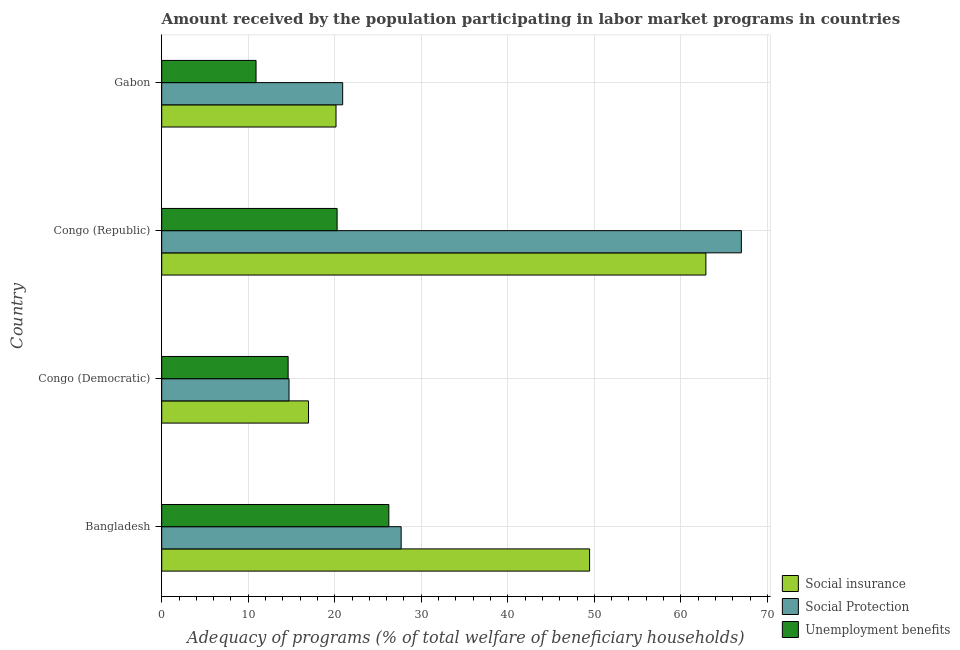How many bars are there on the 3rd tick from the top?
Give a very brief answer. 3. How many bars are there on the 3rd tick from the bottom?
Provide a short and direct response. 3. What is the label of the 2nd group of bars from the top?
Provide a short and direct response. Congo (Republic). What is the amount received by the population participating in unemployment benefits programs in Congo (Democratic)?
Your response must be concise. 14.61. Across all countries, what is the maximum amount received by the population participating in social protection programs?
Your response must be concise. 66.99. Across all countries, what is the minimum amount received by the population participating in unemployment benefits programs?
Give a very brief answer. 10.9. In which country was the amount received by the population participating in social protection programs maximum?
Your answer should be compact. Congo (Republic). In which country was the amount received by the population participating in social insurance programs minimum?
Offer a very short reply. Congo (Democratic). What is the total amount received by the population participating in unemployment benefits programs in the graph?
Your answer should be compact. 72.04. What is the difference between the amount received by the population participating in social insurance programs in Bangladesh and that in Congo (Democratic)?
Ensure brevity in your answer.  32.49. What is the difference between the amount received by the population participating in social insurance programs in Bangladesh and the amount received by the population participating in social protection programs in Congo (Republic)?
Your answer should be very brief. -17.54. What is the average amount received by the population participating in social insurance programs per country?
Ensure brevity in your answer.  37.36. What is the difference between the amount received by the population participating in social insurance programs and amount received by the population participating in unemployment benefits programs in Congo (Republic)?
Ensure brevity in your answer.  42.62. In how many countries, is the amount received by the population participating in unemployment benefits programs greater than 24 %?
Offer a very short reply. 1. What is the ratio of the amount received by the population participating in social protection programs in Congo (Republic) to that in Gabon?
Keep it short and to the point. 3.2. Is the amount received by the population participating in unemployment benefits programs in Congo (Democratic) less than that in Gabon?
Provide a succinct answer. No. Is the difference between the amount received by the population participating in social protection programs in Bangladesh and Gabon greater than the difference between the amount received by the population participating in social insurance programs in Bangladesh and Gabon?
Provide a succinct answer. No. What is the difference between the highest and the second highest amount received by the population participating in social protection programs?
Your response must be concise. 39.32. What is the difference between the highest and the lowest amount received by the population participating in unemployment benefits programs?
Make the answer very short. 15.35. In how many countries, is the amount received by the population participating in social protection programs greater than the average amount received by the population participating in social protection programs taken over all countries?
Your answer should be compact. 1. What does the 1st bar from the top in Gabon represents?
Your response must be concise. Unemployment benefits. What does the 3rd bar from the bottom in Congo (Republic) represents?
Provide a short and direct response. Unemployment benefits. Is it the case that in every country, the sum of the amount received by the population participating in social insurance programs and amount received by the population participating in social protection programs is greater than the amount received by the population participating in unemployment benefits programs?
Provide a succinct answer. Yes. How many bars are there?
Keep it short and to the point. 12. How many countries are there in the graph?
Keep it short and to the point. 4. Are the values on the major ticks of X-axis written in scientific E-notation?
Provide a short and direct response. No. What is the title of the graph?
Ensure brevity in your answer.  Amount received by the population participating in labor market programs in countries. What is the label or title of the X-axis?
Ensure brevity in your answer.  Adequacy of programs (% of total welfare of beneficiary households). What is the label or title of the Y-axis?
Offer a terse response. Country. What is the Adequacy of programs (% of total welfare of beneficiary households) in Social insurance in Bangladesh?
Ensure brevity in your answer.  49.45. What is the Adequacy of programs (% of total welfare of beneficiary households) of Social Protection in Bangladesh?
Your answer should be compact. 27.67. What is the Adequacy of programs (% of total welfare of beneficiary households) in Unemployment benefits in Bangladesh?
Ensure brevity in your answer.  26.25. What is the Adequacy of programs (% of total welfare of beneficiary households) in Social insurance in Congo (Democratic)?
Ensure brevity in your answer.  16.97. What is the Adequacy of programs (% of total welfare of beneficiary households) in Social Protection in Congo (Democratic)?
Make the answer very short. 14.72. What is the Adequacy of programs (% of total welfare of beneficiary households) of Unemployment benefits in Congo (Democratic)?
Your answer should be compact. 14.61. What is the Adequacy of programs (% of total welfare of beneficiary households) of Social insurance in Congo (Republic)?
Offer a terse response. 62.89. What is the Adequacy of programs (% of total welfare of beneficiary households) in Social Protection in Congo (Republic)?
Your answer should be compact. 66.99. What is the Adequacy of programs (% of total welfare of beneficiary households) of Unemployment benefits in Congo (Republic)?
Offer a very short reply. 20.27. What is the Adequacy of programs (% of total welfare of beneficiary households) of Social insurance in Gabon?
Offer a very short reply. 20.14. What is the Adequacy of programs (% of total welfare of beneficiary households) of Social Protection in Gabon?
Offer a very short reply. 20.91. What is the Adequacy of programs (% of total welfare of beneficiary households) of Unemployment benefits in Gabon?
Provide a short and direct response. 10.9. Across all countries, what is the maximum Adequacy of programs (% of total welfare of beneficiary households) of Social insurance?
Give a very brief answer. 62.89. Across all countries, what is the maximum Adequacy of programs (% of total welfare of beneficiary households) in Social Protection?
Offer a terse response. 66.99. Across all countries, what is the maximum Adequacy of programs (% of total welfare of beneficiary households) of Unemployment benefits?
Your answer should be very brief. 26.25. Across all countries, what is the minimum Adequacy of programs (% of total welfare of beneficiary households) in Social insurance?
Your answer should be compact. 16.97. Across all countries, what is the minimum Adequacy of programs (% of total welfare of beneficiary households) in Social Protection?
Keep it short and to the point. 14.72. Across all countries, what is the minimum Adequacy of programs (% of total welfare of beneficiary households) of Unemployment benefits?
Keep it short and to the point. 10.9. What is the total Adequacy of programs (% of total welfare of beneficiary households) in Social insurance in the graph?
Provide a succinct answer. 149.46. What is the total Adequacy of programs (% of total welfare of beneficiary households) in Social Protection in the graph?
Provide a short and direct response. 130.3. What is the total Adequacy of programs (% of total welfare of beneficiary households) in Unemployment benefits in the graph?
Your answer should be compact. 72.04. What is the difference between the Adequacy of programs (% of total welfare of beneficiary households) of Social insurance in Bangladesh and that in Congo (Democratic)?
Your answer should be very brief. 32.49. What is the difference between the Adequacy of programs (% of total welfare of beneficiary households) in Social Protection in Bangladesh and that in Congo (Democratic)?
Ensure brevity in your answer.  12.96. What is the difference between the Adequacy of programs (% of total welfare of beneficiary households) of Unemployment benefits in Bangladesh and that in Congo (Democratic)?
Give a very brief answer. 11.64. What is the difference between the Adequacy of programs (% of total welfare of beneficiary households) in Social insurance in Bangladesh and that in Congo (Republic)?
Give a very brief answer. -13.44. What is the difference between the Adequacy of programs (% of total welfare of beneficiary households) in Social Protection in Bangladesh and that in Congo (Republic)?
Your answer should be very brief. -39.32. What is the difference between the Adequacy of programs (% of total welfare of beneficiary households) of Unemployment benefits in Bangladesh and that in Congo (Republic)?
Offer a very short reply. 5.98. What is the difference between the Adequacy of programs (% of total welfare of beneficiary households) in Social insurance in Bangladesh and that in Gabon?
Provide a short and direct response. 29.31. What is the difference between the Adequacy of programs (% of total welfare of beneficiary households) in Social Protection in Bangladesh and that in Gabon?
Ensure brevity in your answer.  6.76. What is the difference between the Adequacy of programs (% of total welfare of beneficiary households) of Unemployment benefits in Bangladesh and that in Gabon?
Provide a short and direct response. 15.35. What is the difference between the Adequacy of programs (% of total welfare of beneficiary households) in Social insurance in Congo (Democratic) and that in Congo (Republic)?
Your response must be concise. -45.92. What is the difference between the Adequacy of programs (% of total welfare of beneficiary households) in Social Protection in Congo (Democratic) and that in Congo (Republic)?
Make the answer very short. -52.28. What is the difference between the Adequacy of programs (% of total welfare of beneficiary households) of Unemployment benefits in Congo (Democratic) and that in Congo (Republic)?
Provide a succinct answer. -5.66. What is the difference between the Adequacy of programs (% of total welfare of beneficiary households) of Social insurance in Congo (Democratic) and that in Gabon?
Offer a terse response. -3.18. What is the difference between the Adequacy of programs (% of total welfare of beneficiary households) in Social Protection in Congo (Democratic) and that in Gabon?
Give a very brief answer. -6.2. What is the difference between the Adequacy of programs (% of total welfare of beneficiary households) in Unemployment benefits in Congo (Democratic) and that in Gabon?
Your answer should be compact. 3.71. What is the difference between the Adequacy of programs (% of total welfare of beneficiary households) in Social insurance in Congo (Republic) and that in Gabon?
Keep it short and to the point. 42.75. What is the difference between the Adequacy of programs (% of total welfare of beneficiary households) in Social Protection in Congo (Republic) and that in Gabon?
Provide a succinct answer. 46.08. What is the difference between the Adequacy of programs (% of total welfare of beneficiary households) in Unemployment benefits in Congo (Republic) and that in Gabon?
Your answer should be compact. 9.37. What is the difference between the Adequacy of programs (% of total welfare of beneficiary households) of Social insurance in Bangladesh and the Adequacy of programs (% of total welfare of beneficiary households) of Social Protection in Congo (Democratic)?
Provide a short and direct response. 34.74. What is the difference between the Adequacy of programs (% of total welfare of beneficiary households) in Social insurance in Bangladesh and the Adequacy of programs (% of total welfare of beneficiary households) in Unemployment benefits in Congo (Democratic)?
Keep it short and to the point. 34.84. What is the difference between the Adequacy of programs (% of total welfare of beneficiary households) in Social Protection in Bangladesh and the Adequacy of programs (% of total welfare of beneficiary households) in Unemployment benefits in Congo (Democratic)?
Ensure brevity in your answer.  13.06. What is the difference between the Adequacy of programs (% of total welfare of beneficiary households) of Social insurance in Bangladesh and the Adequacy of programs (% of total welfare of beneficiary households) of Social Protection in Congo (Republic)?
Your answer should be compact. -17.54. What is the difference between the Adequacy of programs (% of total welfare of beneficiary households) in Social insurance in Bangladesh and the Adequacy of programs (% of total welfare of beneficiary households) in Unemployment benefits in Congo (Republic)?
Provide a succinct answer. 29.18. What is the difference between the Adequacy of programs (% of total welfare of beneficiary households) of Social Protection in Bangladesh and the Adequacy of programs (% of total welfare of beneficiary households) of Unemployment benefits in Congo (Republic)?
Offer a terse response. 7.4. What is the difference between the Adequacy of programs (% of total welfare of beneficiary households) in Social insurance in Bangladesh and the Adequacy of programs (% of total welfare of beneficiary households) in Social Protection in Gabon?
Give a very brief answer. 28.54. What is the difference between the Adequacy of programs (% of total welfare of beneficiary households) of Social insurance in Bangladesh and the Adequacy of programs (% of total welfare of beneficiary households) of Unemployment benefits in Gabon?
Keep it short and to the point. 38.55. What is the difference between the Adequacy of programs (% of total welfare of beneficiary households) in Social Protection in Bangladesh and the Adequacy of programs (% of total welfare of beneficiary households) in Unemployment benefits in Gabon?
Offer a very short reply. 16.77. What is the difference between the Adequacy of programs (% of total welfare of beneficiary households) of Social insurance in Congo (Democratic) and the Adequacy of programs (% of total welfare of beneficiary households) of Social Protection in Congo (Republic)?
Ensure brevity in your answer.  -50.03. What is the difference between the Adequacy of programs (% of total welfare of beneficiary households) in Social insurance in Congo (Democratic) and the Adequacy of programs (% of total welfare of beneficiary households) in Unemployment benefits in Congo (Republic)?
Offer a terse response. -3.31. What is the difference between the Adequacy of programs (% of total welfare of beneficiary households) of Social Protection in Congo (Democratic) and the Adequacy of programs (% of total welfare of beneficiary households) of Unemployment benefits in Congo (Republic)?
Your answer should be very brief. -5.56. What is the difference between the Adequacy of programs (% of total welfare of beneficiary households) in Social insurance in Congo (Democratic) and the Adequacy of programs (% of total welfare of beneficiary households) in Social Protection in Gabon?
Your response must be concise. -3.95. What is the difference between the Adequacy of programs (% of total welfare of beneficiary households) of Social insurance in Congo (Democratic) and the Adequacy of programs (% of total welfare of beneficiary households) of Unemployment benefits in Gabon?
Give a very brief answer. 6.06. What is the difference between the Adequacy of programs (% of total welfare of beneficiary households) of Social Protection in Congo (Democratic) and the Adequacy of programs (% of total welfare of beneficiary households) of Unemployment benefits in Gabon?
Provide a succinct answer. 3.81. What is the difference between the Adequacy of programs (% of total welfare of beneficiary households) of Social insurance in Congo (Republic) and the Adequacy of programs (% of total welfare of beneficiary households) of Social Protection in Gabon?
Your response must be concise. 41.98. What is the difference between the Adequacy of programs (% of total welfare of beneficiary households) of Social insurance in Congo (Republic) and the Adequacy of programs (% of total welfare of beneficiary households) of Unemployment benefits in Gabon?
Keep it short and to the point. 51.99. What is the difference between the Adequacy of programs (% of total welfare of beneficiary households) of Social Protection in Congo (Republic) and the Adequacy of programs (% of total welfare of beneficiary households) of Unemployment benefits in Gabon?
Provide a short and direct response. 56.09. What is the average Adequacy of programs (% of total welfare of beneficiary households) in Social insurance per country?
Your answer should be very brief. 37.36. What is the average Adequacy of programs (% of total welfare of beneficiary households) in Social Protection per country?
Your response must be concise. 32.57. What is the average Adequacy of programs (% of total welfare of beneficiary households) of Unemployment benefits per country?
Your response must be concise. 18.01. What is the difference between the Adequacy of programs (% of total welfare of beneficiary households) of Social insurance and Adequacy of programs (% of total welfare of beneficiary households) of Social Protection in Bangladesh?
Your answer should be compact. 21.78. What is the difference between the Adequacy of programs (% of total welfare of beneficiary households) in Social insurance and Adequacy of programs (% of total welfare of beneficiary households) in Unemployment benefits in Bangladesh?
Your answer should be compact. 23.2. What is the difference between the Adequacy of programs (% of total welfare of beneficiary households) of Social Protection and Adequacy of programs (% of total welfare of beneficiary households) of Unemployment benefits in Bangladesh?
Your answer should be very brief. 1.42. What is the difference between the Adequacy of programs (% of total welfare of beneficiary households) in Social insurance and Adequacy of programs (% of total welfare of beneficiary households) in Social Protection in Congo (Democratic)?
Offer a terse response. 2.25. What is the difference between the Adequacy of programs (% of total welfare of beneficiary households) of Social insurance and Adequacy of programs (% of total welfare of beneficiary households) of Unemployment benefits in Congo (Democratic)?
Offer a very short reply. 2.36. What is the difference between the Adequacy of programs (% of total welfare of beneficiary households) in Social Protection and Adequacy of programs (% of total welfare of beneficiary households) in Unemployment benefits in Congo (Democratic)?
Your answer should be very brief. 0.11. What is the difference between the Adequacy of programs (% of total welfare of beneficiary households) of Social insurance and Adequacy of programs (% of total welfare of beneficiary households) of Social Protection in Congo (Republic)?
Keep it short and to the point. -4.1. What is the difference between the Adequacy of programs (% of total welfare of beneficiary households) of Social insurance and Adequacy of programs (% of total welfare of beneficiary households) of Unemployment benefits in Congo (Republic)?
Your response must be concise. 42.62. What is the difference between the Adequacy of programs (% of total welfare of beneficiary households) of Social Protection and Adequacy of programs (% of total welfare of beneficiary households) of Unemployment benefits in Congo (Republic)?
Your answer should be compact. 46.72. What is the difference between the Adequacy of programs (% of total welfare of beneficiary households) of Social insurance and Adequacy of programs (% of total welfare of beneficiary households) of Social Protection in Gabon?
Your answer should be compact. -0.77. What is the difference between the Adequacy of programs (% of total welfare of beneficiary households) of Social insurance and Adequacy of programs (% of total welfare of beneficiary households) of Unemployment benefits in Gabon?
Provide a short and direct response. 9.24. What is the difference between the Adequacy of programs (% of total welfare of beneficiary households) in Social Protection and Adequacy of programs (% of total welfare of beneficiary households) in Unemployment benefits in Gabon?
Your answer should be compact. 10.01. What is the ratio of the Adequacy of programs (% of total welfare of beneficiary households) of Social insurance in Bangladesh to that in Congo (Democratic)?
Offer a terse response. 2.91. What is the ratio of the Adequacy of programs (% of total welfare of beneficiary households) of Social Protection in Bangladesh to that in Congo (Democratic)?
Keep it short and to the point. 1.88. What is the ratio of the Adequacy of programs (% of total welfare of beneficiary households) in Unemployment benefits in Bangladesh to that in Congo (Democratic)?
Your response must be concise. 1.8. What is the ratio of the Adequacy of programs (% of total welfare of beneficiary households) in Social insurance in Bangladesh to that in Congo (Republic)?
Ensure brevity in your answer.  0.79. What is the ratio of the Adequacy of programs (% of total welfare of beneficiary households) of Social Protection in Bangladesh to that in Congo (Republic)?
Your answer should be compact. 0.41. What is the ratio of the Adequacy of programs (% of total welfare of beneficiary households) in Unemployment benefits in Bangladesh to that in Congo (Republic)?
Keep it short and to the point. 1.29. What is the ratio of the Adequacy of programs (% of total welfare of beneficiary households) of Social insurance in Bangladesh to that in Gabon?
Your response must be concise. 2.45. What is the ratio of the Adequacy of programs (% of total welfare of beneficiary households) of Social Protection in Bangladesh to that in Gabon?
Offer a terse response. 1.32. What is the ratio of the Adequacy of programs (% of total welfare of beneficiary households) of Unemployment benefits in Bangladesh to that in Gabon?
Ensure brevity in your answer.  2.41. What is the ratio of the Adequacy of programs (% of total welfare of beneficiary households) in Social insurance in Congo (Democratic) to that in Congo (Republic)?
Ensure brevity in your answer.  0.27. What is the ratio of the Adequacy of programs (% of total welfare of beneficiary households) of Social Protection in Congo (Democratic) to that in Congo (Republic)?
Give a very brief answer. 0.22. What is the ratio of the Adequacy of programs (% of total welfare of beneficiary households) in Unemployment benefits in Congo (Democratic) to that in Congo (Republic)?
Your answer should be compact. 0.72. What is the ratio of the Adequacy of programs (% of total welfare of beneficiary households) in Social insurance in Congo (Democratic) to that in Gabon?
Ensure brevity in your answer.  0.84. What is the ratio of the Adequacy of programs (% of total welfare of beneficiary households) in Social Protection in Congo (Democratic) to that in Gabon?
Your answer should be compact. 0.7. What is the ratio of the Adequacy of programs (% of total welfare of beneficiary households) in Unemployment benefits in Congo (Democratic) to that in Gabon?
Keep it short and to the point. 1.34. What is the ratio of the Adequacy of programs (% of total welfare of beneficiary households) of Social insurance in Congo (Republic) to that in Gabon?
Offer a terse response. 3.12. What is the ratio of the Adequacy of programs (% of total welfare of beneficiary households) of Social Protection in Congo (Republic) to that in Gabon?
Provide a short and direct response. 3.2. What is the ratio of the Adequacy of programs (% of total welfare of beneficiary households) in Unemployment benefits in Congo (Republic) to that in Gabon?
Your answer should be very brief. 1.86. What is the difference between the highest and the second highest Adequacy of programs (% of total welfare of beneficiary households) in Social insurance?
Your response must be concise. 13.44. What is the difference between the highest and the second highest Adequacy of programs (% of total welfare of beneficiary households) of Social Protection?
Provide a short and direct response. 39.32. What is the difference between the highest and the second highest Adequacy of programs (% of total welfare of beneficiary households) of Unemployment benefits?
Offer a terse response. 5.98. What is the difference between the highest and the lowest Adequacy of programs (% of total welfare of beneficiary households) of Social insurance?
Give a very brief answer. 45.92. What is the difference between the highest and the lowest Adequacy of programs (% of total welfare of beneficiary households) in Social Protection?
Keep it short and to the point. 52.28. What is the difference between the highest and the lowest Adequacy of programs (% of total welfare of beneficiary households) in Unemployment benefits?
Your response must be concise. 15.35. 